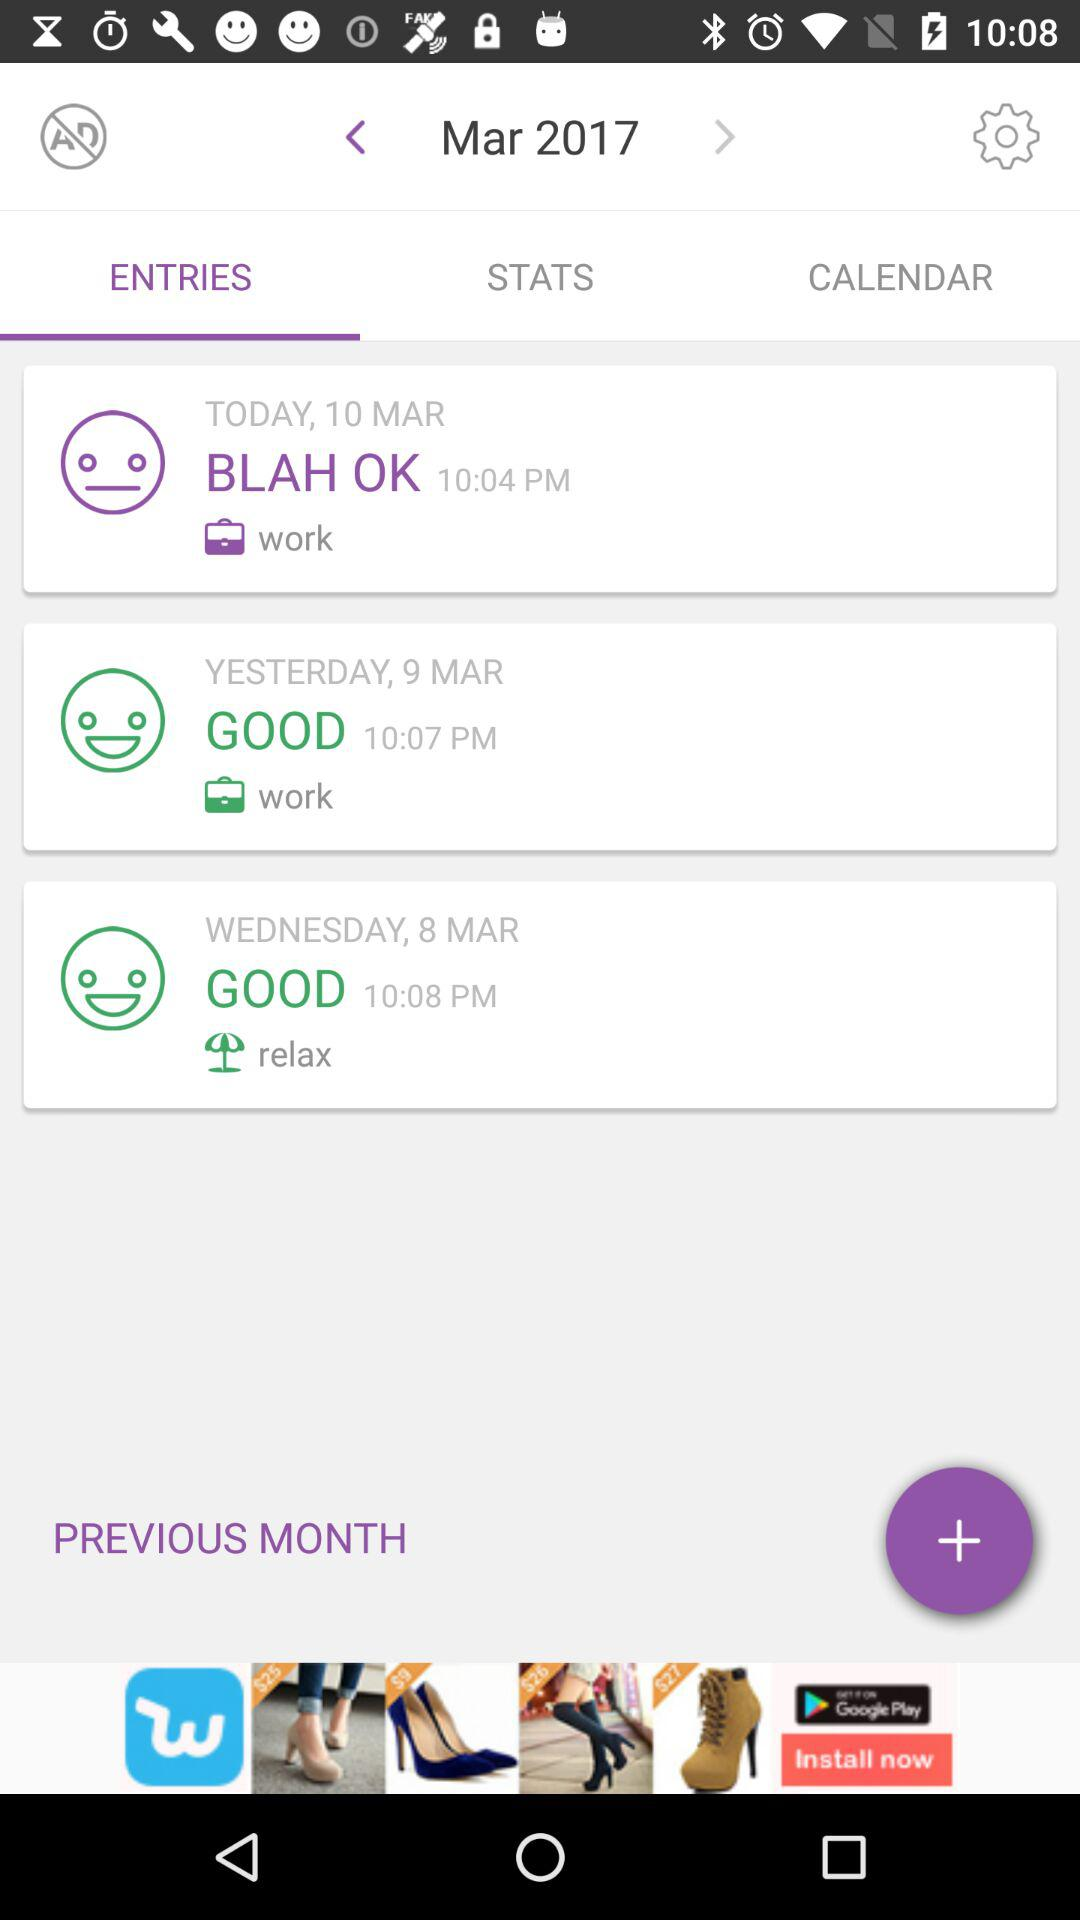What is today's date? Today's date is March 10, 2017. 